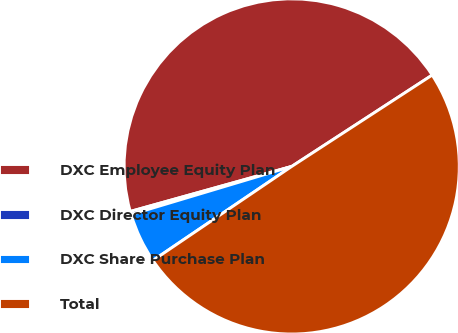Convert chart. <chart><loc_0><loc_0><loc_500><loc_500><pie_chart><fcel>DXC Employee Equity Plan<fcel>DXC Director Equity Plan<fcel>DXC Share Purchase Plan<fcel>Total<nl><fcel>45.15%<fcel>0.3%<fcel>4.85%<fcel>49.7%<nl></chart> 